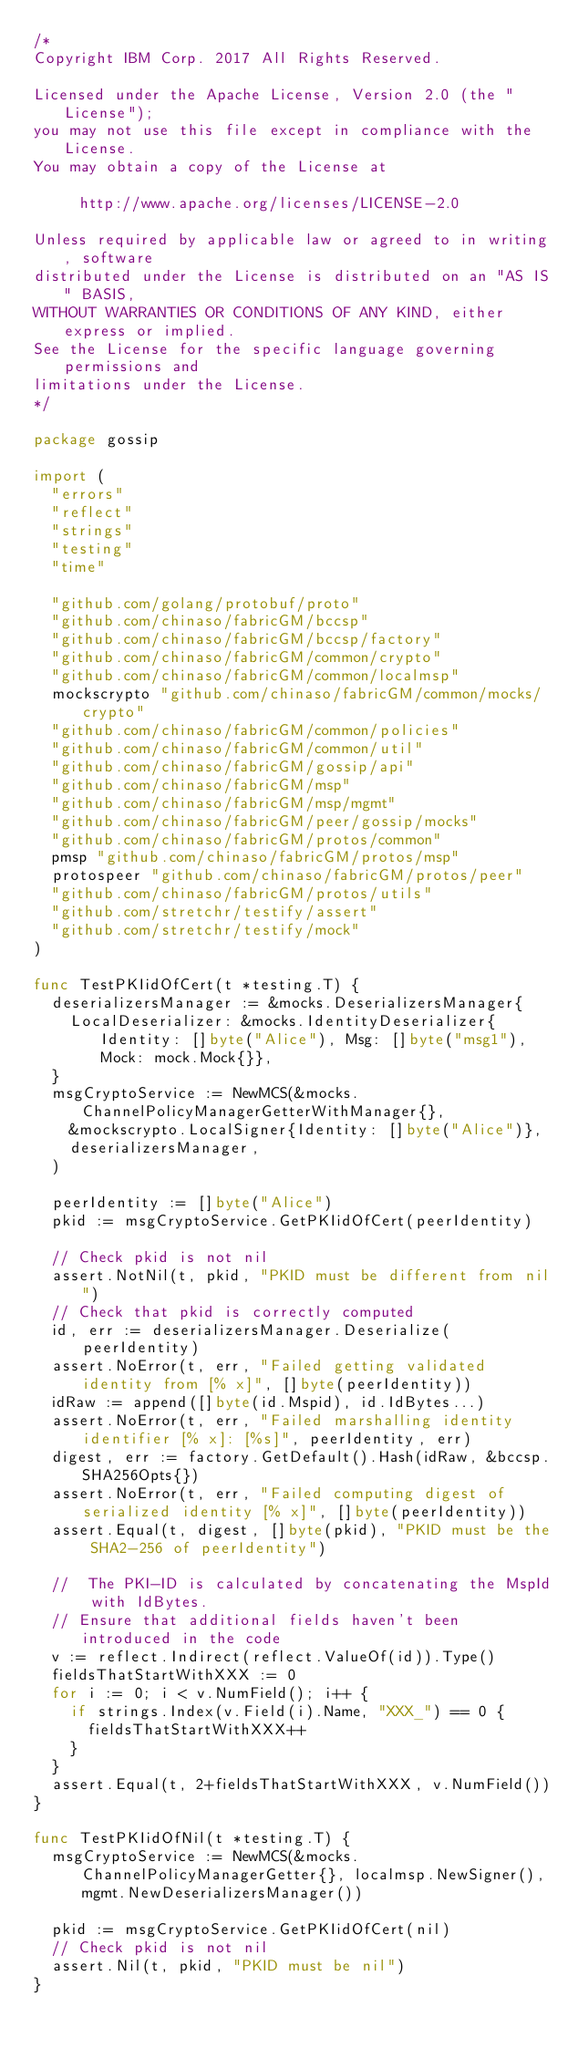Convert code to text. <code><loc_0><loc_0><loc_500><loc_500><_Go_>/*
Copyright IBM Corp. 2017 All Rights Reserved.

Licensed under the Apache License, Version 2.0 (the "License");
you may not use this file except in compliance with the License.
You may obtain a copy of the License at

		 http://www.apache.org/licenses/LICENSE-2.0

Unless required by applicable law or agreed to in writing, software
distributed under the License is distributed on an "AS IS" BASIS,
WITHOUT WARRANTIES OR CONDITIONS OF ANY KIND, either express or implied.
See the License for the specific language governing permissions and
limitations under the License.
*/

package gossip

import (
	"errors"
	"reflect"
	"strings"
	"testing"
	"time"

	"github.com/golang/protobuf/proto"
	"github.com/chinaso/fabricGM/bccsp"
	"github.com/chinaso/fabricGM/bccsp/factory"
	"github.com/chinaso/fabricGM/common/crypto"
	"github.com/chinaso/fabricGM/common/localmsp"
	mockscrypto "github.com/chinaso/fabricGM/common/mocks/crypto"
	"github.com/chinaso/fabricGM/common/policies"
	"github.com/chinaso/fabricGM/common/util"
	"github.com/chinaso/fabricGM/gossip/api"
	"github.com/chinaso/fabricGM/msp"
	"github.com/chinaso/fabricGM/msp/mgmt"
	"github.com/chinaso/fabricGM/peer/gossip/mocks"
	"github.com/chinaso/fabricGM/protos/common"
	pmsp "github.com/chinaso/fabricGM/protos/msp"
	protospeer "github.com/chinaso/fabricGM/protos/peer"
	"github.com/chinaso/fabricGM/protos/utils"
	"github.com/stretchr/testify/assert"
	"github.com/stretchr/testify/mock"
)

func TestPKIidOfCert(t *testing.T) {
	deserializersManager := &mocks.DeserializersManager{
		LocalDeserializer: &mocks.IdentityDeserializer{Identity: []byte("Alice"), Msg: []byte("msg1"), Mock: mock.Mock{}},
	}
	msgCryptoService := NewMCS(&mocks.ChannelPolicyManagerGetterWithManager{},
		&mockscrypto.LocalSigner{Identity: []byte("Alice")},
		deserializersManager,
	)

	peerIdentity := []byte("Alice")
	pkid := msgCryptoService.GetPKIidOfCert(peerIdentity)

	// Check pkid is not nil
	assert.NotNil(t, pkid, "PKID must be different from nil")
	// Check that pkid is correctly computed
	id, err := deserializersManager.Deserialize(peerIdentity)
	assert.NoError(t, err, "Failed getting validated identity from [% x]", []byte(peerIdentity))
	idRaw := append([]byte(id.Mspid), id.IdBytes...)
	assert.NoError(t, err, "Failed marshalling identity identifier [% x]: [%s]", peerIdentity, err)
	digest, err := factory.GetDefault().Hash(idRaw, &bccsp.SHA256Opts{})
	assert.NoError(t, err, "Failed computing digest of serialized identity [% x]", []byte(peerIdentity))
	assert.Equal(t, digest, []byte(pkid), "PKID must be the SHA2-256 of peerIdentity")

	//  The PKI-ID is calculated by concatenating the MspId with IdBytes.
	// Ensure that additional fields haven't been introduced in the code
	v := reflect.Indirect(reflect.ValueOf(id)).Type()
	fieldsThatStartWithXXX := 0
	for i := 0; i < v.NumField(); i++ {
		if strings.Index(v.Field(i).Name, "XXX_") == 0 {
			fieldsThatStartWithXXX++
		}
	}
	assert.Equal(t, 2+fieldsThatStartWithXXX, v.NumField())
}

func TestPKIidOfNil(t *testing.T) {
	msgCryptoService := NewMCS(&mocks.ChannelPolicyManagerGetter{}, localmsp.NewSigner(), mgmt.NewDeserializersManager())

	pkid := msgCryptoService.GetPKIidOfCert(nil)
	// Check pkid is not nil
	assert.Nil(t, pkid, "PKID must be nil")
}
</code> 